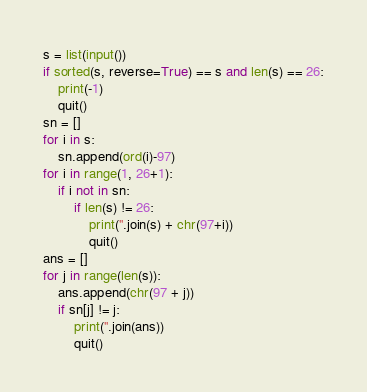<code> <loc_0><loc_0><loc_500><loc_500><_Python_>s = list(input())
if sorted(s, reverse=True) == s and len(s) == 26:
    print(-1)
    quit()
sn = []
for i in s:
    sn.append(ord(i)-97)
for i in range(1, 26+1):
    if i not in sn:
        if len(s) != 26:
            print(''.join(s) + chr(97+i))
            quit()
ans = []
for j in range(len(s)):
    ans.append(chr(97 + j))
    if sn[j] != j:
        print(''.join(ans))
        quit()</code> 